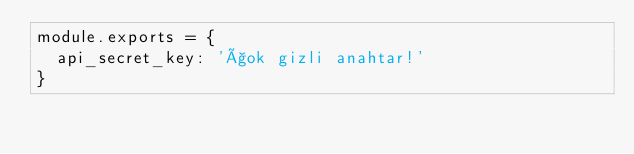Convert code to text. <code><loc_0><loc_0><loc_500><loc_500><_JavaScript_>module.exports = {
  api_secret_key: 'çok gizli anahtar!'
}</code> 